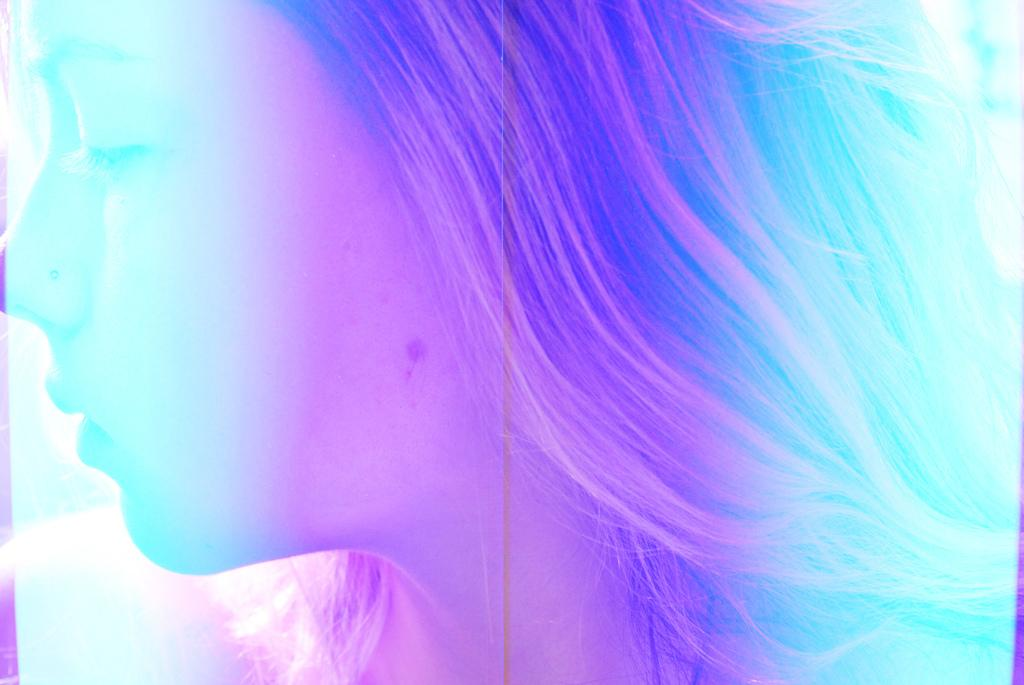Who is the main subject in the image? There is a girl in the image. What type of pin can be seen holding the girl's hair in the image? There is no pin visible in the girl's hair in the image. 